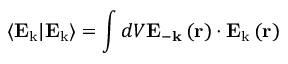<formula> <loc_0><loc_0><loc_500><loc_500>\left \langle E _ { k } | E _ { k } \right \rangle = \int d V E _ { - k } \left ( r \right ) \cdot E _ { k } \left ( r \right )</formula> 